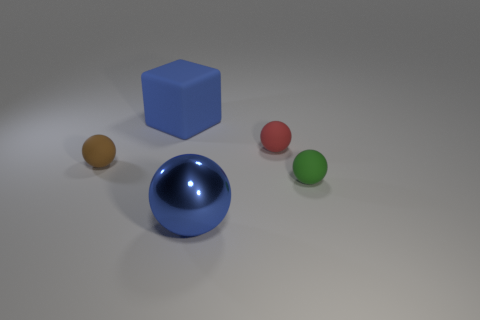What time of day does the lighting in the scene suggest? The scene has a neutral and soft shadow cast that lacks the warm or cool tones typically associated with sunrise or sunset. Therefore, it suggests an interior setup with artificial lighting rather than a specific time of day. 